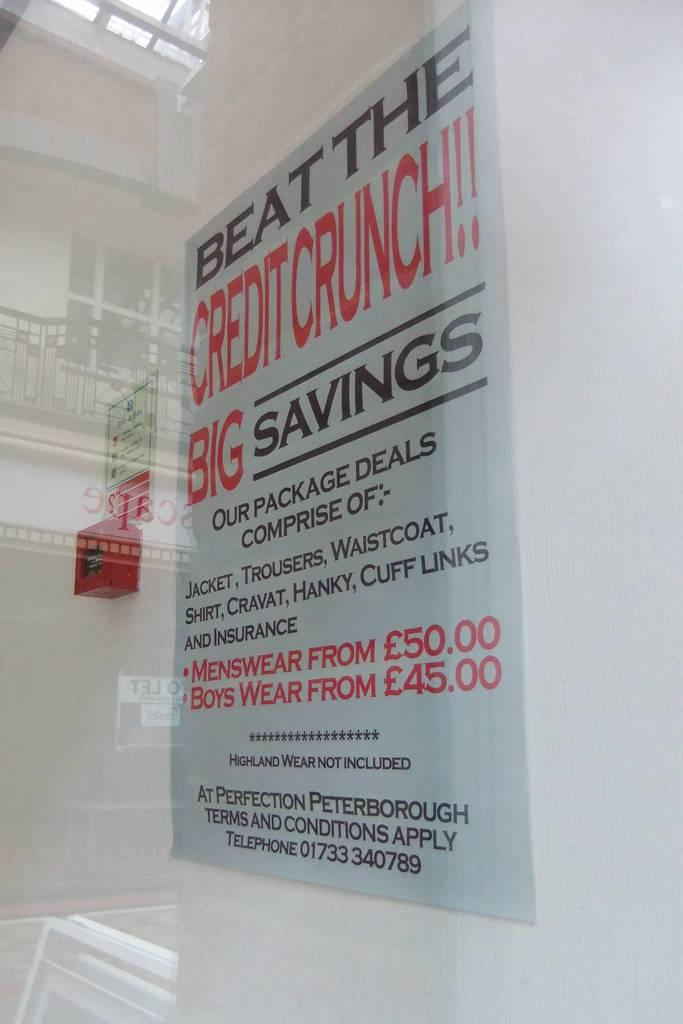What type of location is depicted in the image? The image shows the interior of a building. What can be seen on the walls in the image? There are boards visible in the image, and something is written on them. What color is the wall in the image? There is a white wall in the image. What type of locket is hanging from the frame in the image? There is no locket or frame present in the image; it only shows boards on a white wall. What type of operation is being performed in the image? There is no operation or medical procedure depicted in the image. 